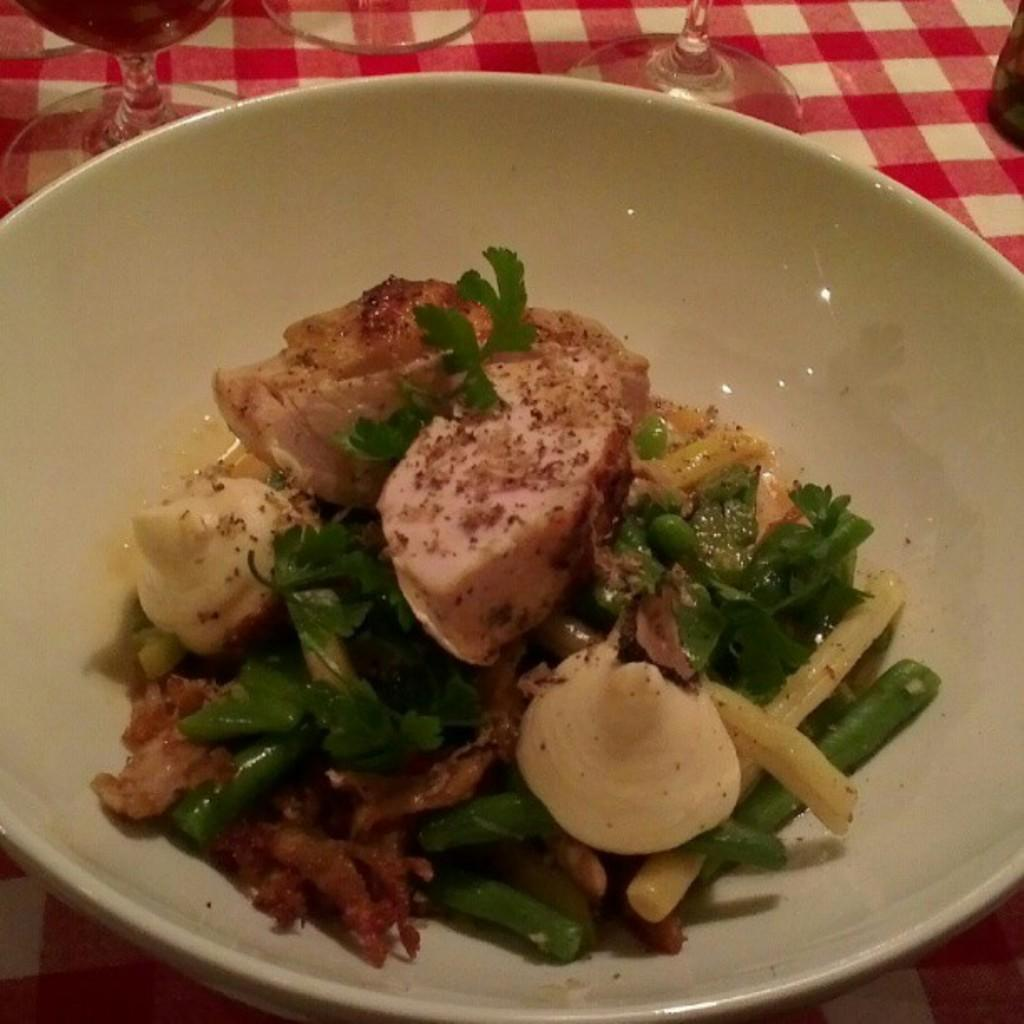What is in the bowl that is visible in the image? There is a bowl with food in the image. What other items can be seen in the image besides the bowl? There are glasses on a cloth in the image. What type of quince is being served in the bowl? There is no quince present in the image; the bowl contains food, but the specific type of food is not mentioned. 